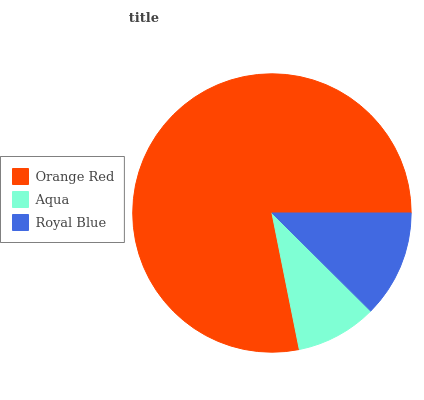Is Aqua the minimum?
Answer yes or no. Yes. Is Orange Red the maximum?
Answer yes or no. Yes. Is Royal Blue the minimum?
Answer yes or no. No. Is Royal Blue the maximum?
Answer yes or no. No. Is Royal Blue greater than Aqua?
Answer yes or no. Yes. Is Aqua less than Royal Blue?
Answer yes or no. Yes. Is Aqua greater than Royal Blue?
Answer yes or no. No. Is Royal Blue less than Aqua?
Answer yes or no. No. Is Royal Blue the high median?
Answer yes or no. Yes. Is Royal Blue the low median?
Answer yes or no. Yes. Is Aqua the high median?
Answer yes or no. No. Is Aqua the low median?
Answer yes or no. No. 